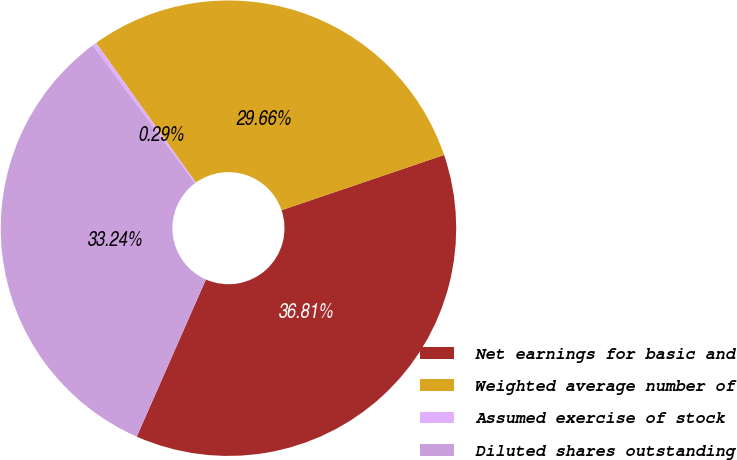Convert chart. <chart><loc_0><loc_0><loc_500><loc_500><pie_chart><fcel>Net earnings for basic and<fcel>Weighted average number of<fcel>Assumed exercise of stock<fcel>Diluted shares outstanding<nl><fcel>36.81%<fcel>29.66%<fcel>0.29%<fcel>33.24%<nl></chart> 